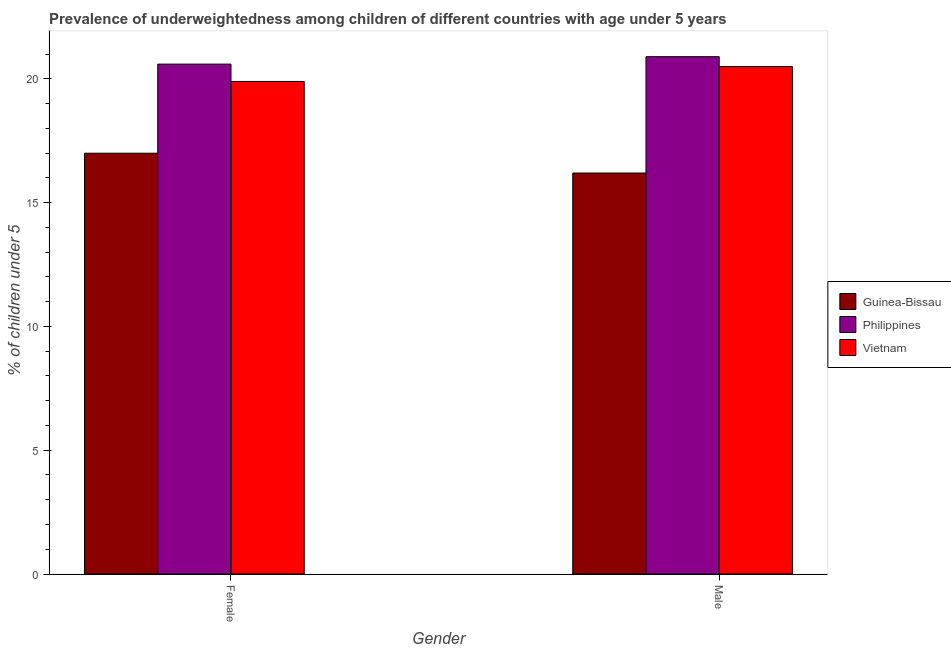How many different coloured bars are there?
Your answer should be compact. 3. How many groups of bars are there?
Make the answer very short. 2. Are the number of bars per tick equal to the number of legend labels?
Ensure brevity in your answer.  Yes. How many bars are there on the 1st tick from the right?
Provide a short and direct response. 3. What is the label of the 1st group of bars from the left?
Keep it short and to the point. Female. What is the percentage of underweighted female children in Vietnam?
Provide a short and direct response. 19.9. Across all countries, what is the maximum percentage of underweighted female children?
Offer a very short reply. 20.6. Across all countries, what is the minimum percentage of underweighted male children?
Ensure brevity in your answer.  16.2. In which country was the percentage of underweighted male children minimum?
Provide a short and direct response. Guinea-Bissau. What is the total percentage of underweighted male children in the graph?
Keep it short and to the point. 57.6. What is the difference between the percentage of underweighted female children in Guinea-Bissau and that in Vietnam?
Your answer should be very brief. -2.9. What is the difference between the percentage of underweighted male children in Guinea-Bissau and the percentage of underweighted female children in Vietnam?
Your answer should be very brief. -3.7. What is the average percentage of underweighted male children per country?
Provide a short and direct response. 19.2. What is the difference between the percentage of underweighted male children and percentage of underweighted female children in Philippines?
Provide a succinct answer. 0.3. What is the ratio of the percentage of underweighted male children in Vietnam to that in Philippines?
Your answer should be very brief. 0.98. What does the 1st bar from the left in Male represents?
Your response must be concise. Guinea-Bissau. What does the 1st bar from the right in Female represents?
Provide a succinct answer. Vietnam. How many bars are there?
Give a very brief answer. 6. Are all the bars in the graph horizontal?
Provide a short and direct response. No. How many countries are there in the graph?
Offer a very short reply. 3. Does the graph contain grids?
Give a very brief answer. No. Where does the legend appear in the graph?
Your answer should be very brief. Center right. How are the legend labels stacked?
Ensure brevity in your answer.  Vertical. What is the title of the graph?
Provide a short and direct response. Prevalence of underweightedness among children of different countries with age under 5 years. What is the label or title of the Y-axis?
Your response must be concise.  % of children under 5. What is the  % of children under 5 in Guinea-Bissau in Female?
Your answer should be very brief. 17. What is the  % of children under 5 in Philippines in Female?
Make the answer very short. 20.6. What is the  % of children under 5 in Vietnam in Female?
Offer a terse response. 19.9. What is the  % of children under 5 of Guinea-Bissau in Male?
Give a very brief answer. 16.2. What is the  % of children under 5 of Philippines in Male?
Your answer should be compact. 20.9. What is the  % of children under 5 in Vietnam in Male?
Offer a terse response. 20.5. Across all Gender, what is the maximum  % of children under 5 of Guinea-Bissau?
Make the answer very short. 17. Across all Gender, what is the maximum  % of children under 5 of Philippines?
Provide a short and direct response. 20.9. Across all Gender, what is the minimum  % of children under 5 of Guinea-Bissau?
Your answer should be compact. 16.2. Across all Gender, what is the minimum  % of children under 5 in Philippines?
Provide a short and direct response. 20.6. Across all Gender, what is the minimum  % of children under 5 in Vietnam?
Offer a very short reply. 19.9. What is the total  % of children under 5 of Guinea-Bissau in the graph?
Your answer should be compact. 33.2. What is the total  % of children under 5 of Philippines in the graph?
Offer a very short reply. 41.5. What is the total  % of children under 5 in Vietnam in the graph?
Provide a short and direct response. 40.4. What is the difference between the  % of children under 5 in Philippines in Female and that in Male?
Offer a terse response. -0.3. What is the difference between the  % of children under 5 of Guinea-Bissau in Female and the  % of children under 5 of Philippines in Male?
Your response must be concise. -3.9. What is the difference between the  % of children under 5 in Philippines in Female and the  % of children under 5 in Vietnam in Male?
Make the answer very short. 0.1. What is the average  % of children under 5 in Philippines per Gender?
Keep it short and to the point. 20.75. What is the average  % of children under 5 of Vietnam per Gender?
Keep it short and to the point. 20.2. What is the difference between the  % of children under 5 of Guinea-Bissau and  % of children under 5 of Philippines in Female?
Ensure brevity in your answer.  -3.6. What is the difference between the  % of children under 5 in Guinea-Bissau and  % of children under 5 in Vietnam in Female?
Keep it short and to the point. -2.9. What is the difference between the  % of children under 5 in Guinea-Bissau and  % of children under 5 in Philippines in Male?
Offer a terse response. -4.7. What is the difference between the  % of children under 5 in Guinea-Bissau and  % of children under 5 in Vietnam in Male?
Make the answer very short. -4.3. What is the difference between the  % of children under 5 in Philippines and  % of children under 5 in Vietnam in Male?
Your response must be concise. 0.4. What is the ratio of the  % of children under 5 in Guinea-Bissau in Female to that in Male?
Make the answer very short. 1.05. What is the ratio of the  % of children under 5 in Philippines in Female to that in Male?
Keep it short and to the point. 0.99. What is the ratio of the  % of children under 5 in Vietnam in Female to that in Male?
Your answer should be very brief. 0.97. What is the difference between the highest and the second highest  % of children under 5 in Vietnam?
Your answer should be compact. 0.6. What is the difference between the highest and the lowest  % of children under 5 in Guinea-Bissau?
Make the answer very short. 0.8. What is the difference between the highest and the lowest  % of children under 5 of Vietnam?
Your answer should be very brief. 0.6. 